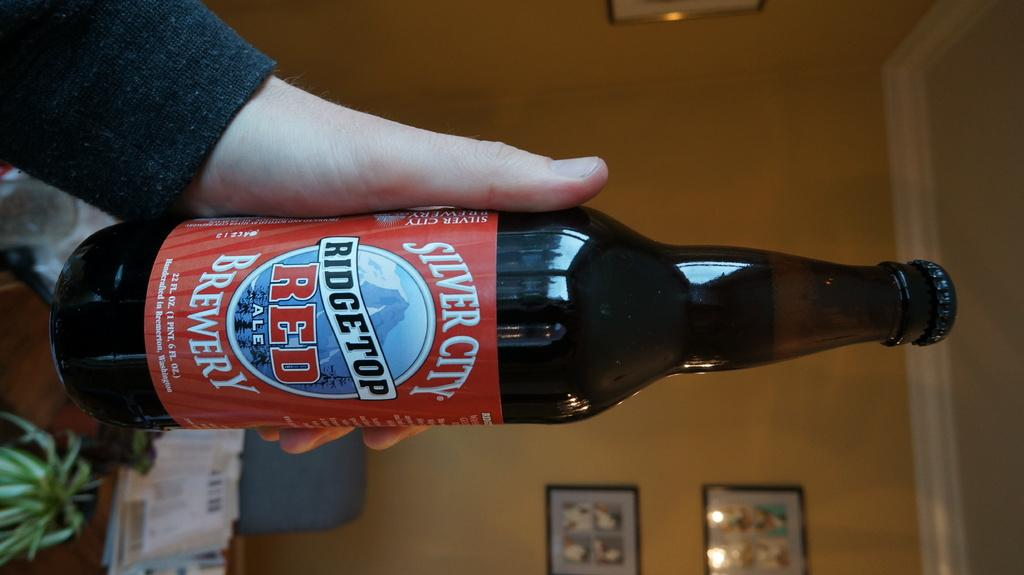Provide a one-sentence caption for the provided image. Person holding a Ridgetop Red ale from Silver City Brewery. 